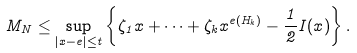<formula> <loc_0><loc_0><loc_500><loc_500>M _ { N } \leq \sup _ { | x - e | \leq t } \left \{ \zeta _ { 1 } x + \cdots + \zeta _ { k } x ^ { e ( H _ { k } ) } - \frac { 1 } { 2 } I ( x ) \right \} .</formula> 